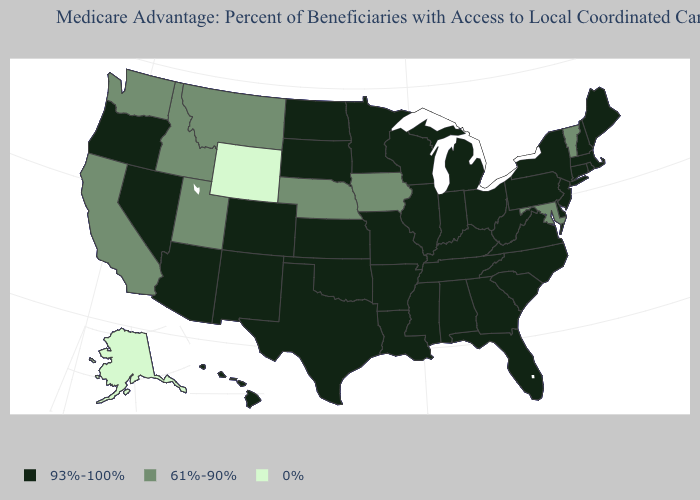What is the value of Montana?
Concise answer only. 61%-90%. Name the states that have a value in the range 93%-100%?
Concise answer only. Colorado, Connecticut, Delaware, Florida, Georgia, Hawaii, Illinois, Indiana, Kansas, Kentucky, Louisiana, Massachusetts, Maine, Michigan, Minnesota, Missouri, Mississippi, North Carolina, North Dakota, New Hampshire, New Jersey, New Mexico, Nevada, New York, Ohio, Oklahoma, Oregon, Pennsylvania, Rhode Island, South Carolina, South Dakota, Tennessee, Texas, Virginia, Wisconsin, West Virginia, Alabama, Arkansas, Arizona. Does Maryland have the same value as Montana?
Give a very brief answer. Yes. What is the value of Iowa?
Keep it brief. 61%-90%. What is the highest value in the MidWest ?
Quick response, please. 93%-100%. What is the highest value in the South ?
Answer briefly. 93%-100%. What is the lowest value in the USA?
Be succinct. 0%. Does Minnesota have a lower value than North Carolina?
Short answer required. No. Does the map have missing data?
Short answer required. No. Name the states that have a value in the range 0%?
Write a very short answer. Alaska, Wyoming. Which states have the lowest value in the USA?
Be succinct. Alaska, Wyoming. Does Vermont have the lowest value in the Northeast?
Answer briefly. Yes. Name the states that have a value in the range 93%-100%?
Give a very brief answer. Colorado, Connecticut, Delaware, Florida, Georgia, Hawaii, Illinois, Indiana, Kansas, Kentucky, Louisiana, Massachusetts, Maine, Michigan, Minnesota, Missouri, Mississippi, North Carolina, North Dakota, New Hampshire, New Jersey, New Mexico, Nevada, New York, Ohio, Oklahoma, Oregon, Pennsylvania, Rhode Island, South Carolina, South Dakota, Tennessee, Texas, Virginia, Wisconsin, West Virginia, Alabama, Arkansas, Arizona. What is the value of North Dakota?
Keep it brief. 93%-100%. Name the states that have a value in the range 0%?
Write a very short answer. Alaska, Wyoming. 